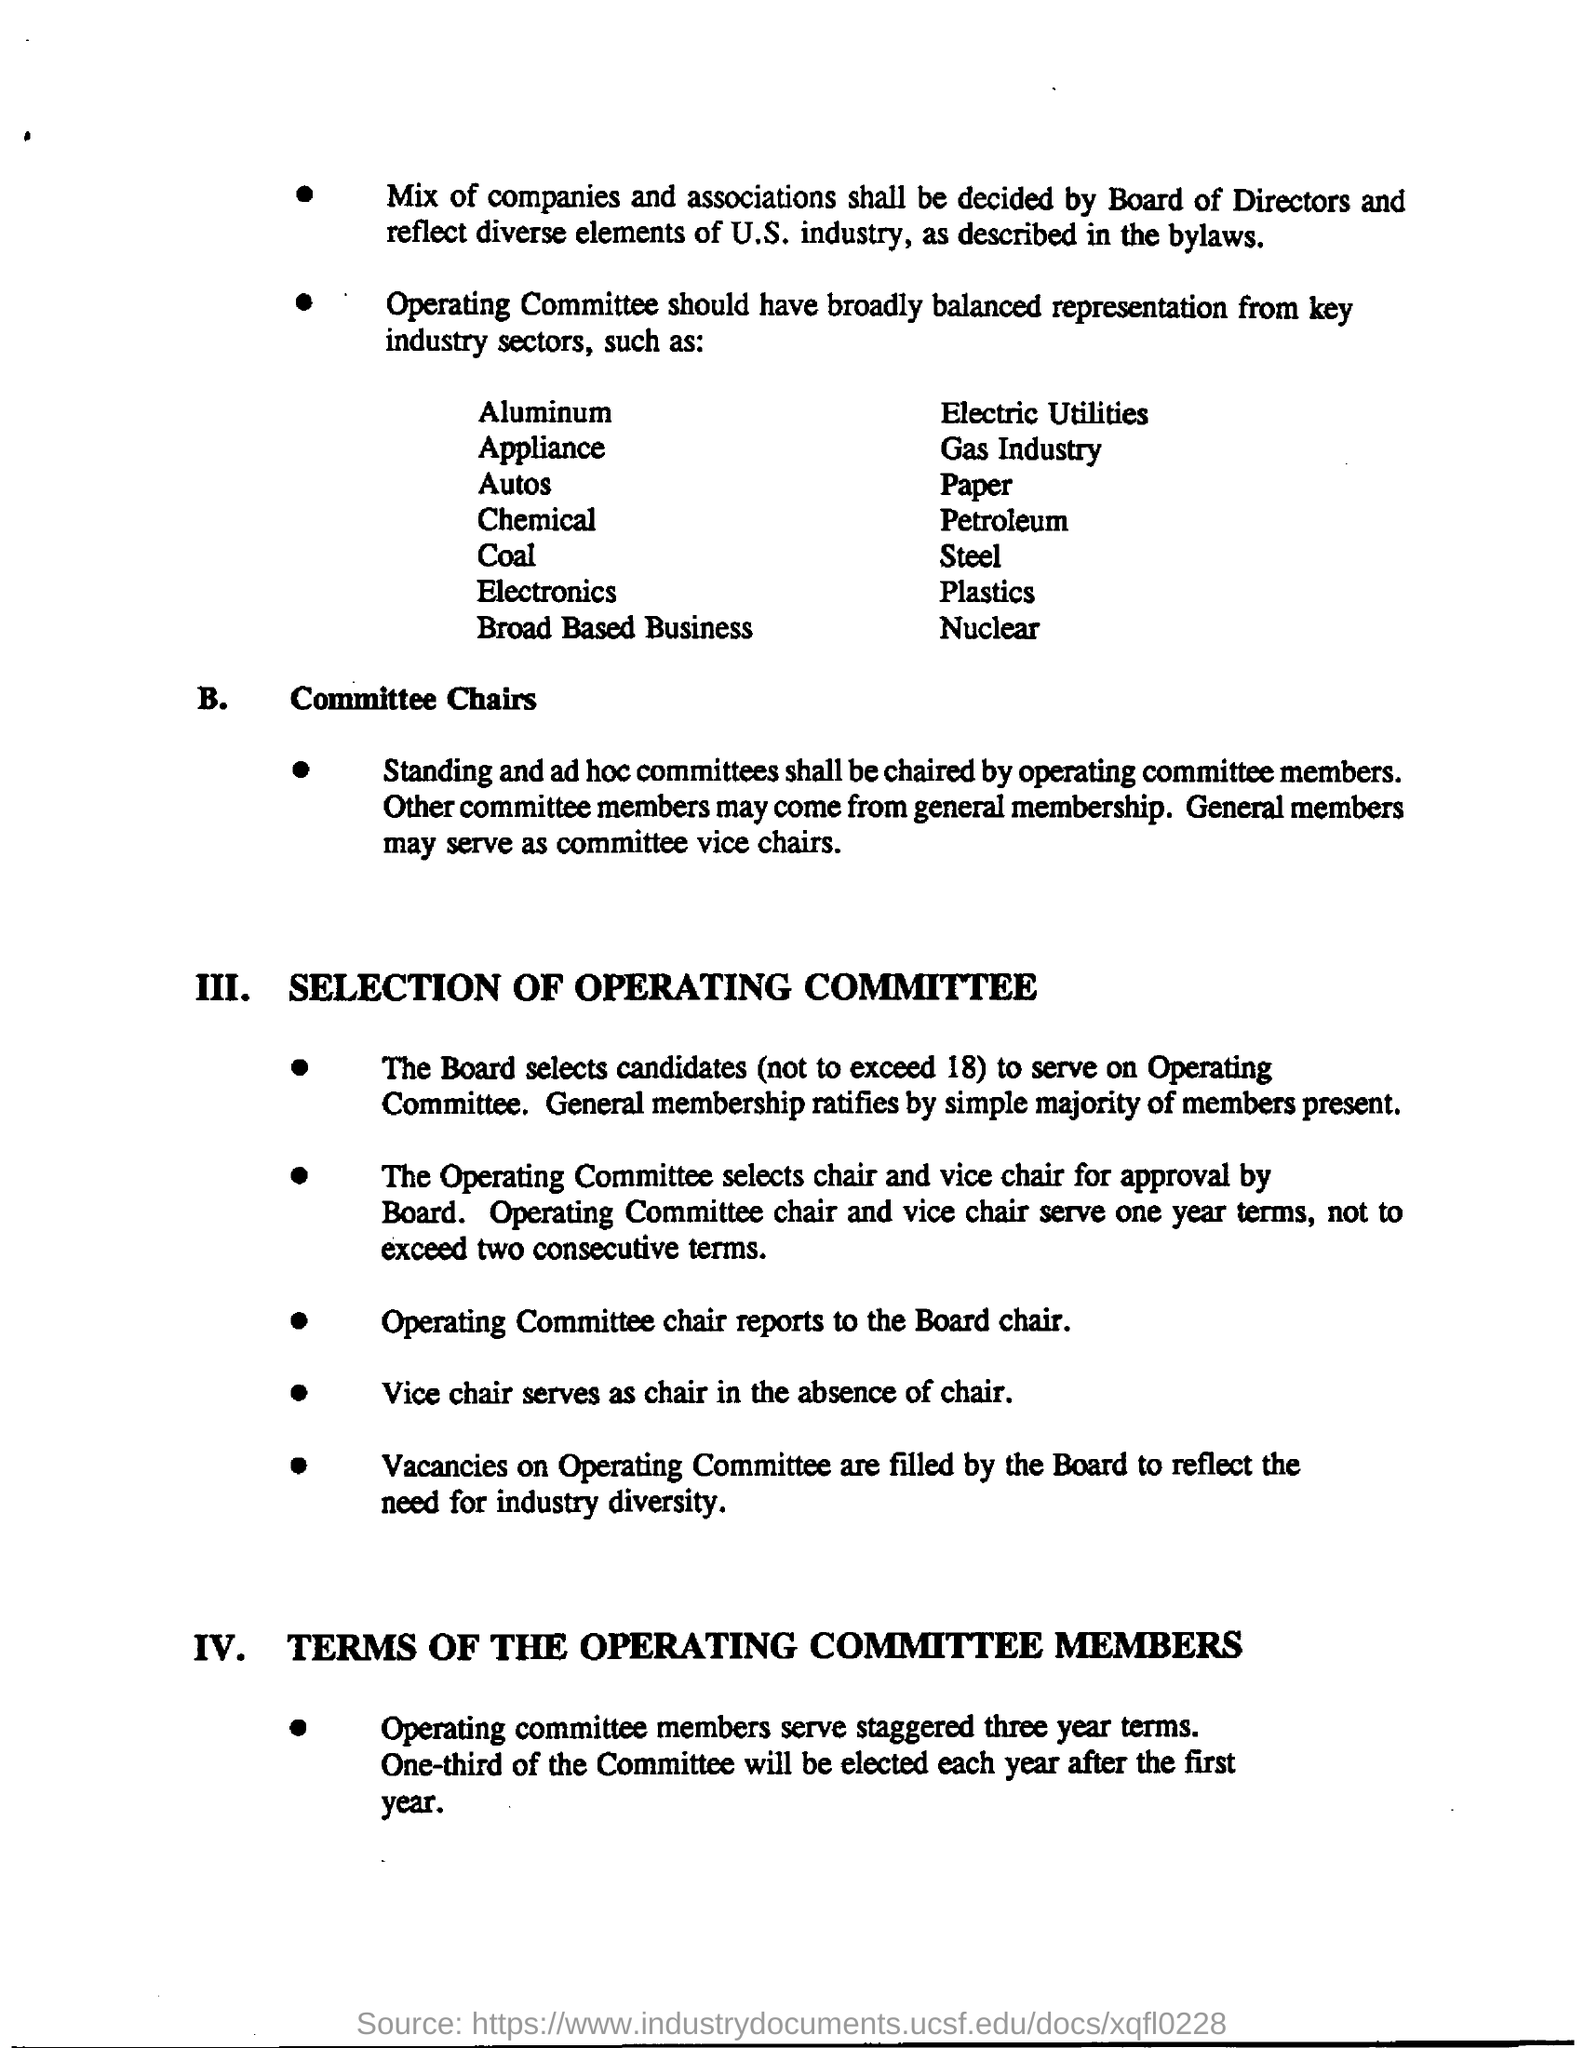Indicate a few pertinent items in this graphic. The Operating Committee reports to the board chair. 